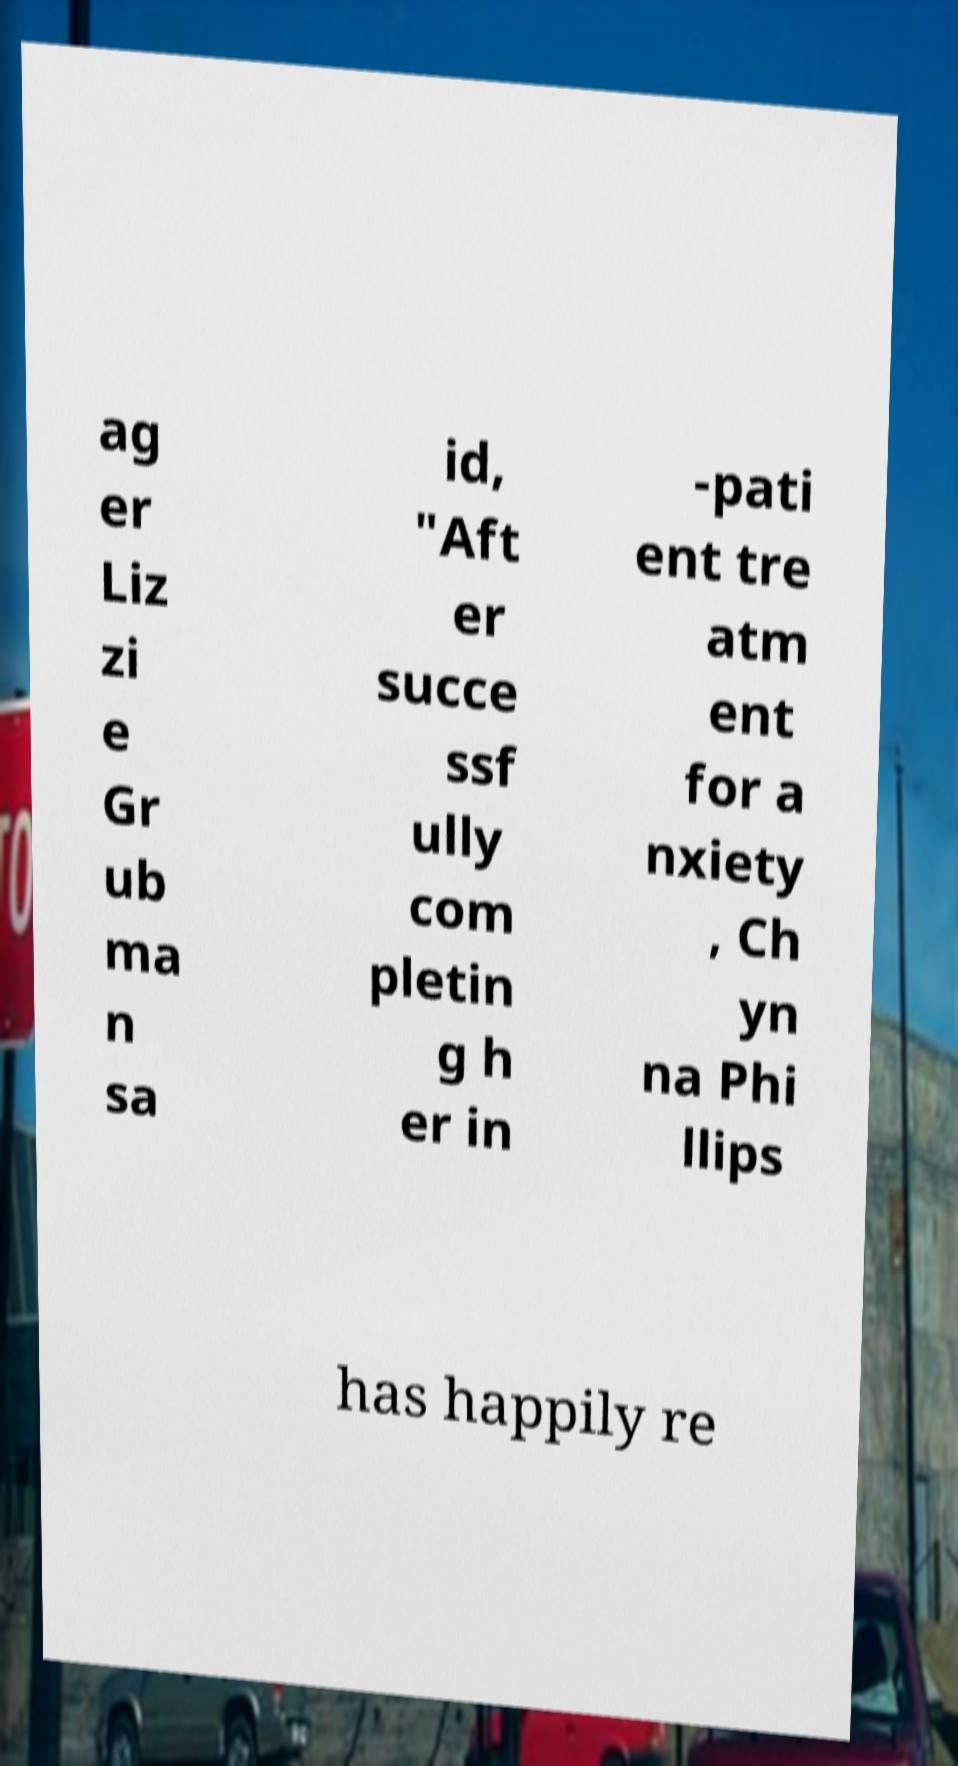Please read and relay the text visible in this image. What does it say? ag er Liz zi e Gr ub ma n sa id, "Aft er succe ssf ully com pletin g h er in -pati ent tre atm ent for a nxiety , Ch yn na Phi llips has happily re 